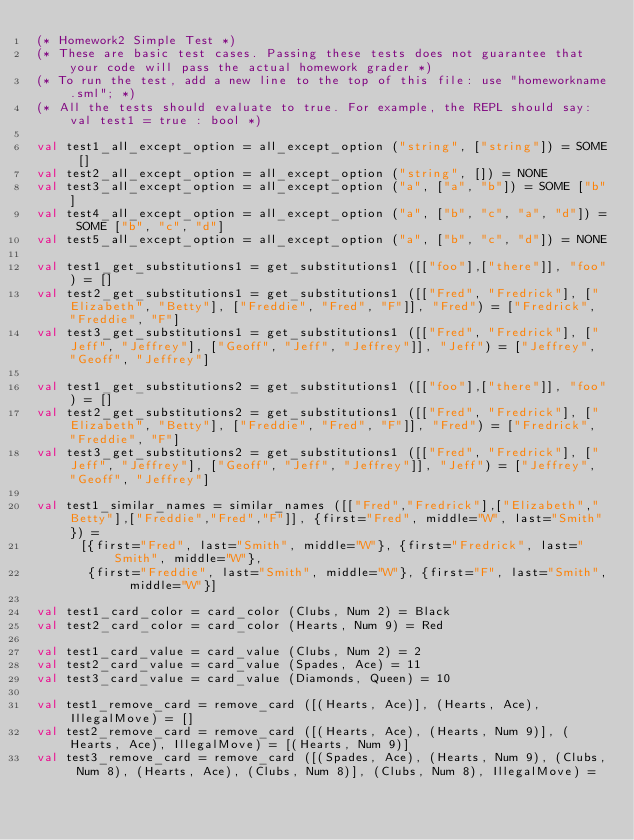Convert code to text. <code><loc_0><loc_0><loc_500><loc_500><_SML_>(* Homework2 Simple Test *)
(* These are basic test cases. Passing these tests does not guarantee that your code will pass the actual homework grader *)
(* To run the test, add a new line to the top of this file: use "homeworkname.sml"; *)
(* All the tests should evaluate to true. For example, the REPL should say: val test1 = true : bool *)

val test1_all_except_option = all_except_option ("string", ["string"]) = SOME []
val test2_all_except_option = all_except_option ("string", []) = NONE
val test3_all_except_option = all_except_option ("a", ["a", "b"]) = SOME ["b"]
val test4_all_except_option = all_except_option ("a", ["b", "c", "a", "d"]) = SOME ["b", "c", "d"]
val test5_all_except_option = all_except_option ("a", ["b", "c", "d"]) = NONE                                                                                   
                                                            
val test1_get_substitutions1 = get_substitutions1 ([["foo"],["there"]], "foo") = []
val test2_get_substitutions1 = get_substitutions1 ([["Fred", "Fredrick"], ["Elizabeth", "Betty"], ["Freddie", "Fred", "F"]], "Fred") = ["Fredrick", "Freddie", "F"]
val test3_get_substitutions1 = get_substitutions1 ([["Fred", "Fredrick"], ["Jeff", "Jeffrey"], ["Geoff", "Jeff", "Jeffrey"]], "Jeff") = ["Jeffrey", "Geoff", "Jeffrey"]

val test1_get_substitutions2 = get_substitutions1 ([["foo"],["there"]], "foo") = []
val test2_get_substitutions2 = get_substitutions1 ([["Fred", "Fredrick"], ["Elizabeth", "Betty"], ["Freddie", "Fred", "F"]], "Fred") = ["Fredrick", "Freddie", "F"]
val test3_get_substitutions2 = get_substitutions1 ([["Fred", "Fredrick"], ["Jeff", "Jeffrey"], ["Geoff", "Jeff", "Jeffrey"]], "Jeff") = ["Jeffrey", "Geoff", "Jeffrey"]

val test1_similar_names = similar_names ([["Fred","Fredrick"],["Elizabeth","Betty"],["Freddie","Fred","F"]], {first="Fred", middle="W", last="Smith"}) =
	    [{first="Fred", last="Smith", middle="W"}, {first="Fredrick", last="Smith", middle="W"},
	     {first="Freddie", last="Smith", middle="W"}, {first="F", last="Smith", middle="W"}]

val test1_card_color = card_color (Clubs, Num 2) = Black
val test2_card_color = card_color (Hearts, Num 9) = Red

val test1_card_value = card_value (Clubs, Num 2) = 2
val test2_card_value = card_value (Spades, Ace) = 11
val test3_card_value = card_value (Diamonds, Queen) = 10

val test1_remove_card = remove_card ([(Hearts, Ace)], (Hearts, Ace), IllegalMove) = []
val test2_remove_card = remove_card ([(Hearts, Ace), (Hearts, Num 9)], (Hearts, Ace), IllegalMove) = [(Hearts, Num 9)]
val test3_remove_card = remove_card ([(Spades, Ace), (Hearts, Num 9), (Clubs, Num 8), (Hearts, Ace), (Clubs, Num 8)], (Clubs, Num 8), IllegalMove) =</code> 